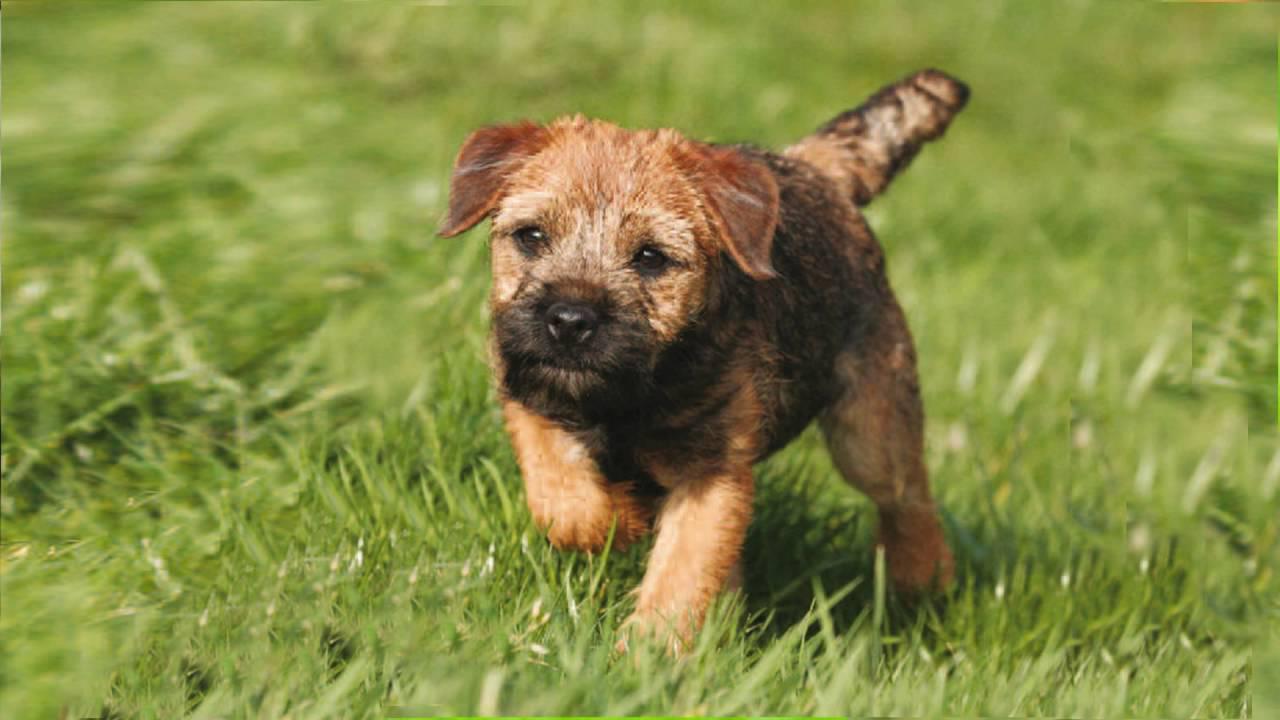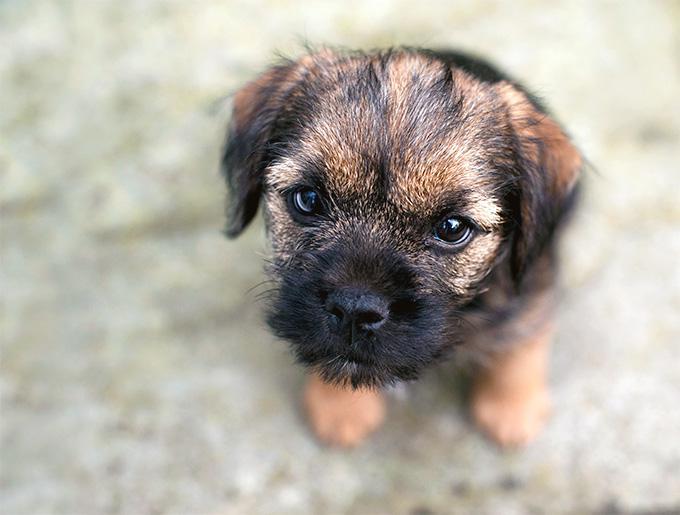The first image is the image on the left, the second image is the image on the right. Evaluate the accuracy of this statement regarding the images: "A puppy runs in the grass toward the photographer.". Is it true? Answer yes or no. Yes. The first image is the image on the left, the second image is the image on the right. For the images displayed, is the sentence "Both puppies are in green grass with no collar visible." factually correct? Answer yes or no. No. 